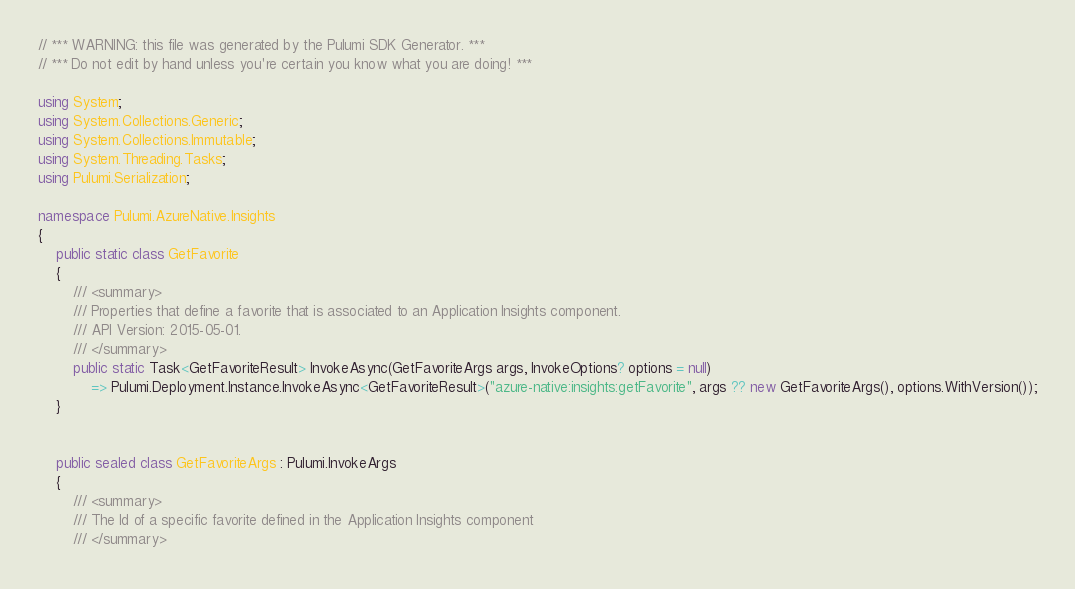Convert code to text. <code><loc_0><loc_0><loc_500><loc_500><_C#_>// *** WARNING: this file was generated by the Pulumi SDK Generator. ***
// *** Do not edit by hand unless you're certain you know what you are doing! ***

using System;
using System.Collections.Generic;
using System.Collections.Immutable;
using System.Threading.Tasks;
using Pulumi.Serialization;

namespace Pulumi.AzureNative.Insights
{
    public static class GetFavorite
    {
        /// <summary>
        /// Properties that define a favorite that is associated to an Application Insights component.
        /// API Version: 2015-05-01.
        /// </summary>
        public static Task<GetFavoriteResult> InvokeAsync(GetFavoriteArgs args, InvokeOptions? options = null)
            => Pulumi.Deployment.Instance.InvokeAsync<GetFavoriteResult>("azure-native:insights:getFavorite", args ?? new GetFavoriteArgs(), options.WithVersion());
    }


    public sealed class GetFavoriteArgs : Pulumi.InvokeArgs
    {
        /// <summary>
        /// The Id of a specific favorite defined in the Application Insights component
        /// </summary></code> 